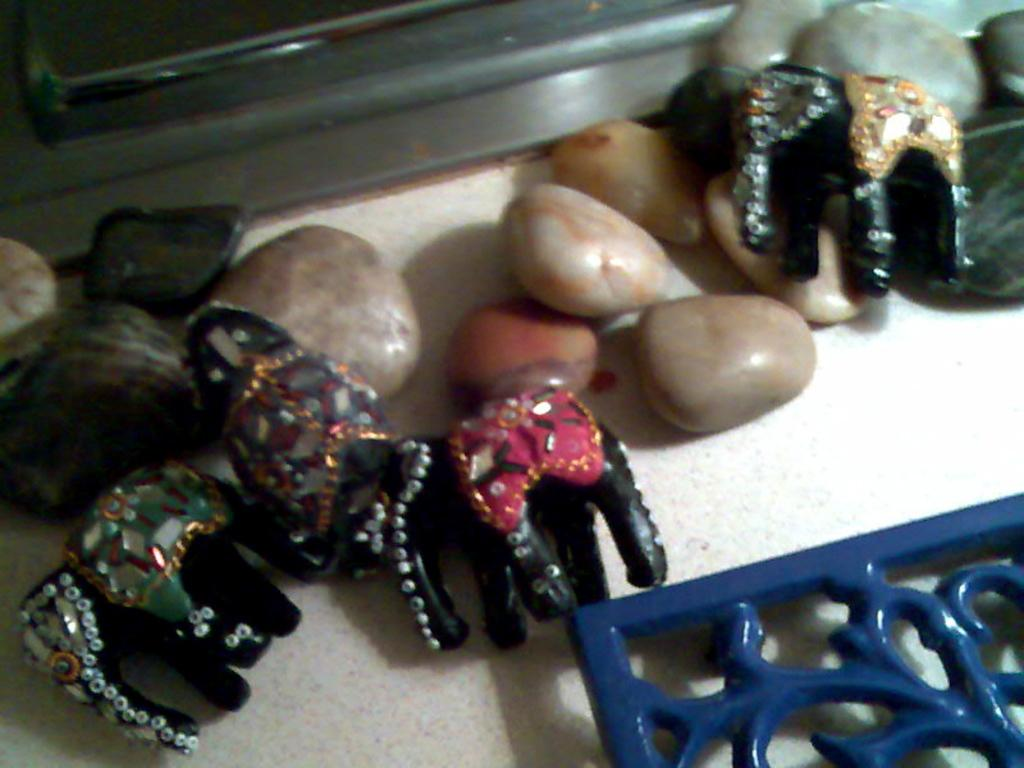What type of dolls are in the image? There are elephant dolls in the image. What small objects can be seen in the image? There are pebbles in the image. Where is the blue color frame located in the image? The blue color frame is at the right bottom of the image. What type of activity is the rod performing in the image? There is no rod present in the image, so it is not possible to answer that question. 